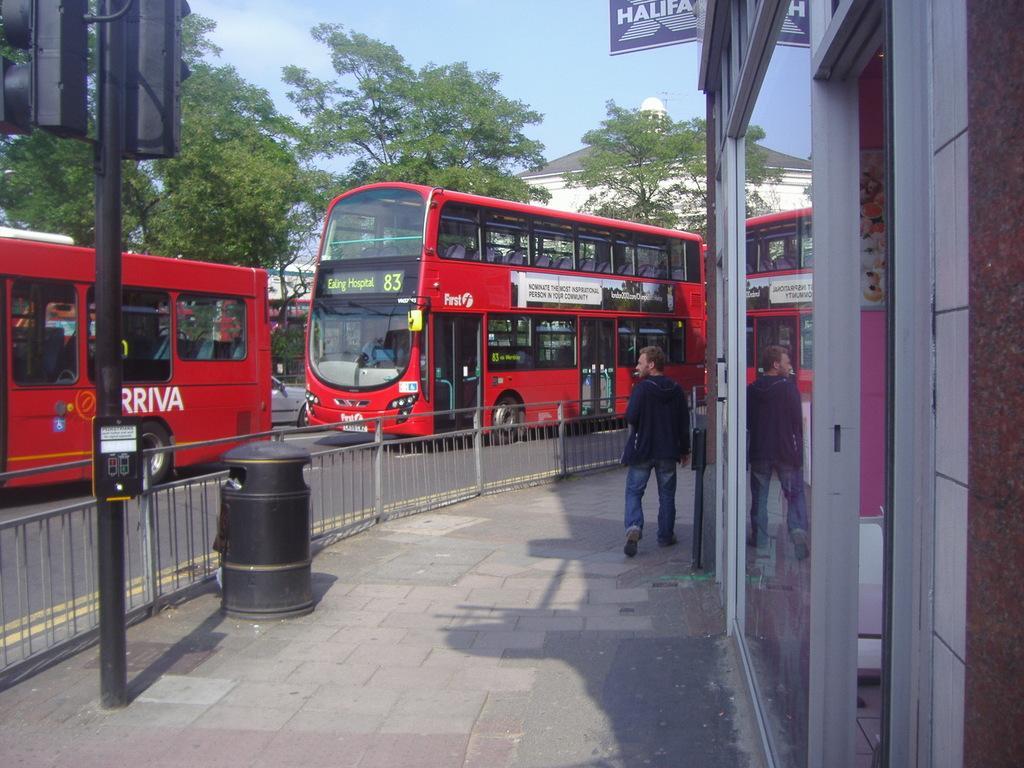In one or two sentences, can you explain what this image depicts? In the center of the image we can see the buses, trees, house. On the left side of the image we can see the traffic lights, pole. In the center of the image we can see a road, barricades. On the right side of the image we can see a building, board, door and a person is walking. At the bottom of the image we can see the footpath. At the top of the image we can see the clouds are present in the sky. 